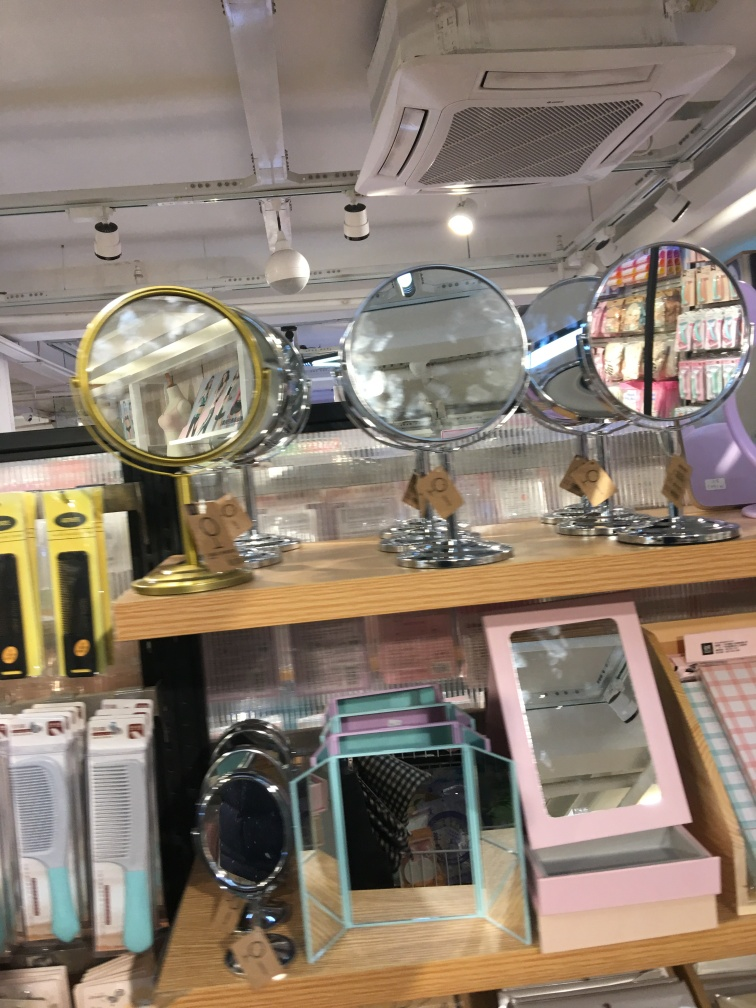What does the arrangement of items in this photo suggest about the store's organization? The store seems to be organized thematically, with a focus on personal grooming and beauty products. The arrangement suggests an attempt to create a pleasant and functional shopping experience. By grouping similar items together, it aids in navigation and possibly targets specific customer interests or needs. The organization appears to be intuitive, with items likely positioned at accessible heights and angles for consumers to easily handle and inspect. 